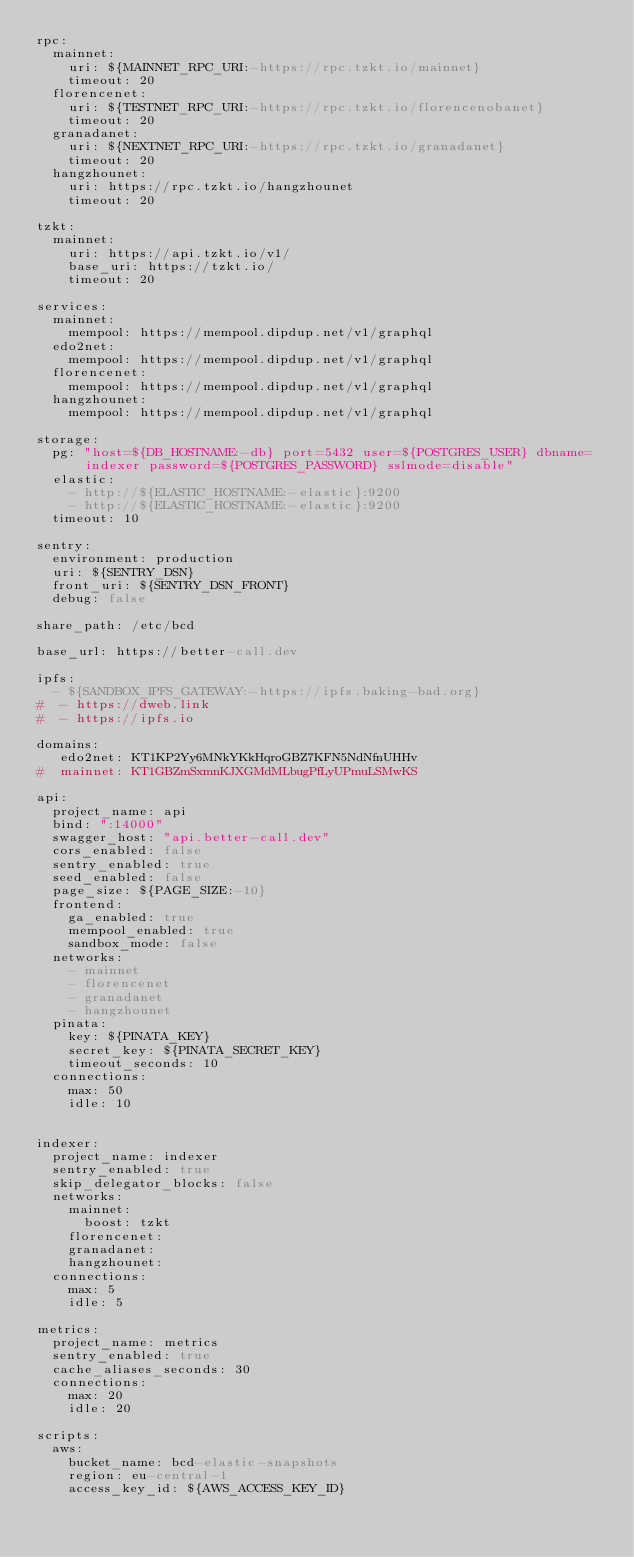<code> <loc_0><loc_0><loc_500><loc_500><_YAML_>rpc:
  mainnet:
    uri: ${MAINNET_RPC_URI:-https://rpc.tzkt.io/mainnet}
    timeout: 20
  florencenet:
    uri: ${TESTNET_RPC_URI:-https://rpc.tzkt.io/florencenobanet}
    timeout: 20
  granadanet:
    uri: ${NEXTNET_RPC_URI:-https://rpc.tzkt.io/granadanet}
    timeout: 20
  hangzhounet:
    uri: https://rpc.tzkt.io/hangzhounet
    timeout: 20

tzkt:
  mainnet:
    uri: https://api.tzkt.io/v1/
    base_uri: https://tzkt.io/
    timeout: 20

services:
  mainnet:
    mempool: https://mempool.dipdup.net/v1/graphql
  edo2net:
    mempool: https://mempool.dipdup.net/v1/graphql
  florencenet:
    mempool: https://mempool.dipdup.net/v1/graphql
  hangzhounet:
    mempool: https://mempool.dipdup.net/v1/graphql 

storage:
  pg: "host=${DB_HOSTNAME:-db} port=5432 user=${POSTGRES_USER} dbname=indexer password=${POSTGRES_PASSWORD} sslmode=disable"
  elastic:
    - http://${ELASTIC_HOSTNAME:-elastic}:9200
    - http://${ELASTIC_HOSTNAME:-elastic}:9200
  timeout: 10

sentry:
  environment: production
  uri: ${SENTRY_DSN}
  front_uri: ${SENTRY_DSN_FRONT}
  debug: false

share_path: /etc/bcd

base_url: https://better-call.dev

ipfs:
  - ${SANDBOX_IPFS_GATEWAY:-https://ipfs.baking-bad.org}
#  - https://dweb.link
#  - https://ipfs.io

domains:
   edo2net: KT1KP2Yy6MNkYKkHqroGBZ7KFN5NdNfnUHHv
#  mainnet: KT1GBZmSxmnKJXGMdMLbugPfLyUPmuLSMwKS

api:
  project_name: api
  bind: ":14000"
  swagger_host: "api.better-call.dev"
  cors_enabled: false
  sentry_enabled: true
  seed_enabled: false
  page_size: ${PAGE_SIZE:-10}
  frontend:
    ga_enabled: true
    mempool_enabled: true
    sandbox_mode: false
  networks:
    - mainnet
    - florencenet
    - granadanet
    - hangzhounet
  pinata:
    key: ${PINATA_KEY}
    secret_key: ${PINATA_SECRET_KEY}
    timeout_seconds: 10
  connections:
    max: 50
    idle: 10


indexer:
  project_name: indexer
  sentry_enabled: true
  skip_delegator_blocks: false
  networks:
    mainnet:
      boost: tzkt
    florencenet:
    granadanet:
    hangzhounet:
  connections:
    max: 5
    idle: 5

metrics:
  project_name: metrics
  sentry_enabled: true
  cache_aliases_seconds: 30
  connections:
    max: 20
    idle: 20

scripts:
  aws:
    bucket_name: bcd-elastic-snapshots
    region: eu-central-1
    access_key_id: ${AWS_ACCESS_KEY_ID}</code> 